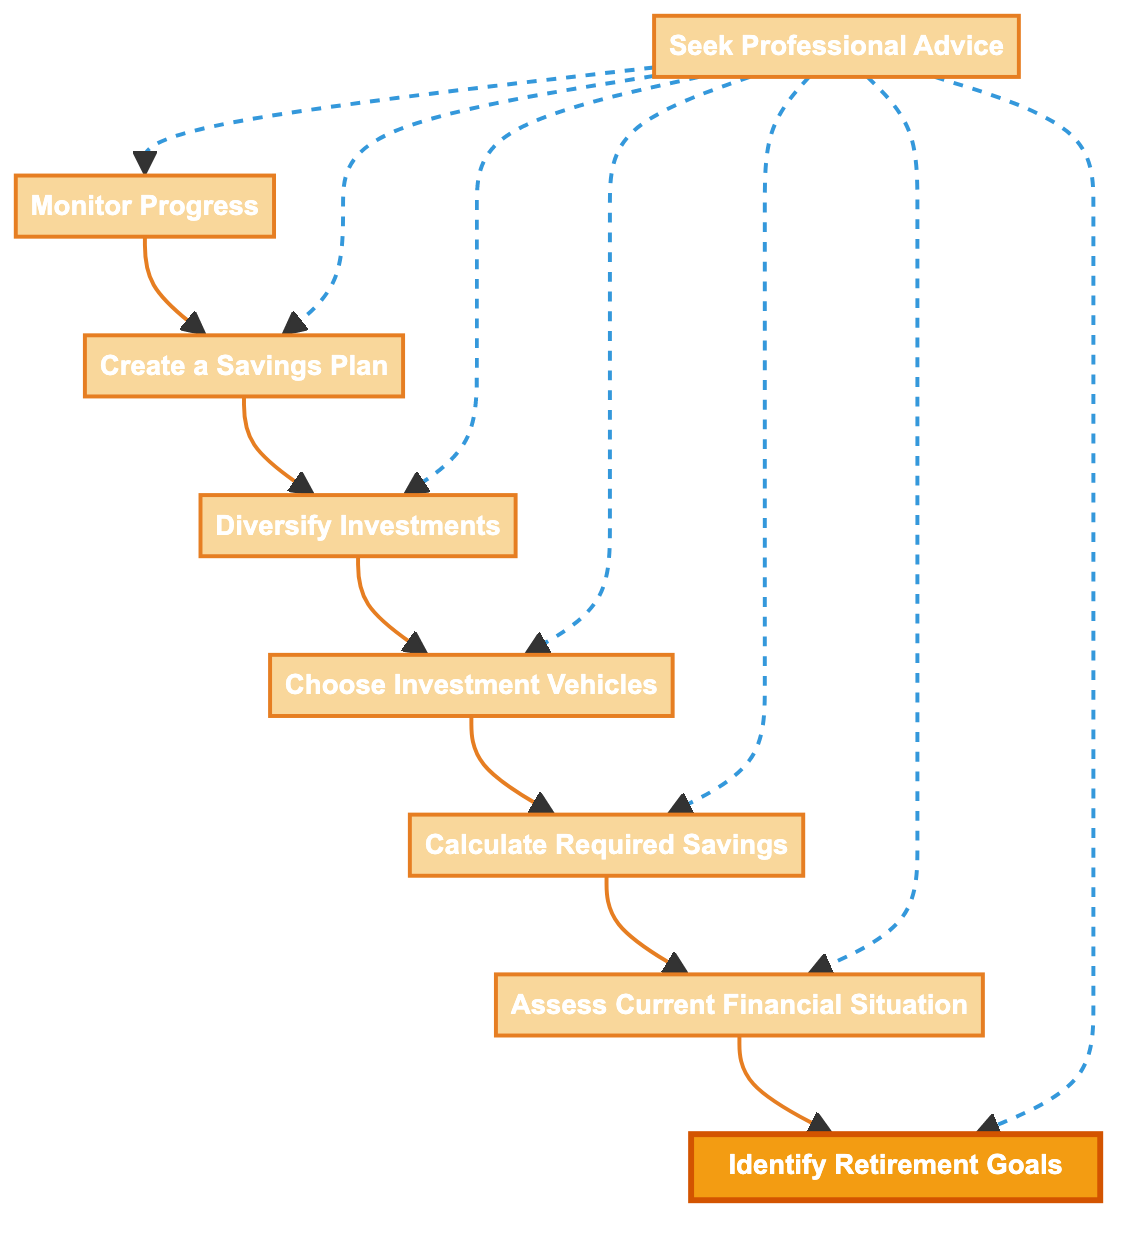What is the first step in the flow chart? The flow chart starts with "Identify Retirement Goals", which is the first node in the diagram.
Answer: Identify Retirement Goals How many steps are there in the retirement planning process? There are a total of 8 steps represented by the nodes in the flow chart.
Answer: 8 What is the last step before seeking professional advice? The last step before "Seek Professional Advice" is "Monitor Progress", indicating it’s a final action to assess before getting external help.
Answer: Monitor Progress What follows after creating a savings plan? After "Create a Savings Plan", the next step is "Diversify Investments", which means spreading the savings into different assets.
Answer: Diversify Investments Which step is connected directly to both "Assess Current Financial Situation" and "Calculate Required Savings"? "Choose Investment Vehicles" is the step that follows both "Assess Current Financial Situation" and "Calculate Required Savings" and is a key decision point in the process.
Answer: Choose Investment Vehicles How does the professional advice relate to the other steps in the diagram? The "Seek Professional Advice" step connects with all the other steps, indicating it can impact or guide each part of the planning process where needed.
Answer: It connects with all steps What type of relationship is indicated between "Seek Professional Advice" and the other steps? The relationship between "Seek Professional Advice" and the other steps is shown as a dashed line, which typically indicates a suggestive or advisory connection rather than a direct flow progression.
Answer: Dashed advisory relationship What is the purpose of "Calculate Required Savings"? The purpose of "Calculate Required Savings" is to estimate the total amount needed for a comfortable retirement, based on life expectancy and expected expenses.
Answer: Estimate retirement amount 